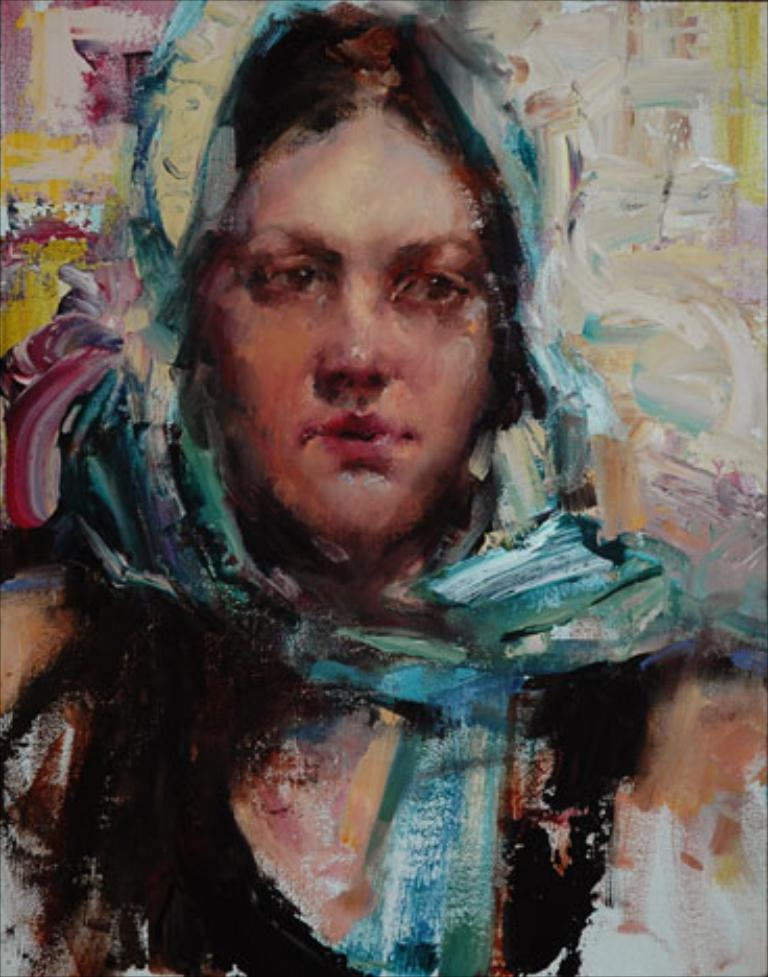What is the main subject of the art piece in the image? The art piece depicts a woman. What can be observed about the colors used in the art piece? The art piece uses different colors. What type of bird can be seen flying near the woman in the art piece? There is no bird present in the art piece; it only depicts a woman. 